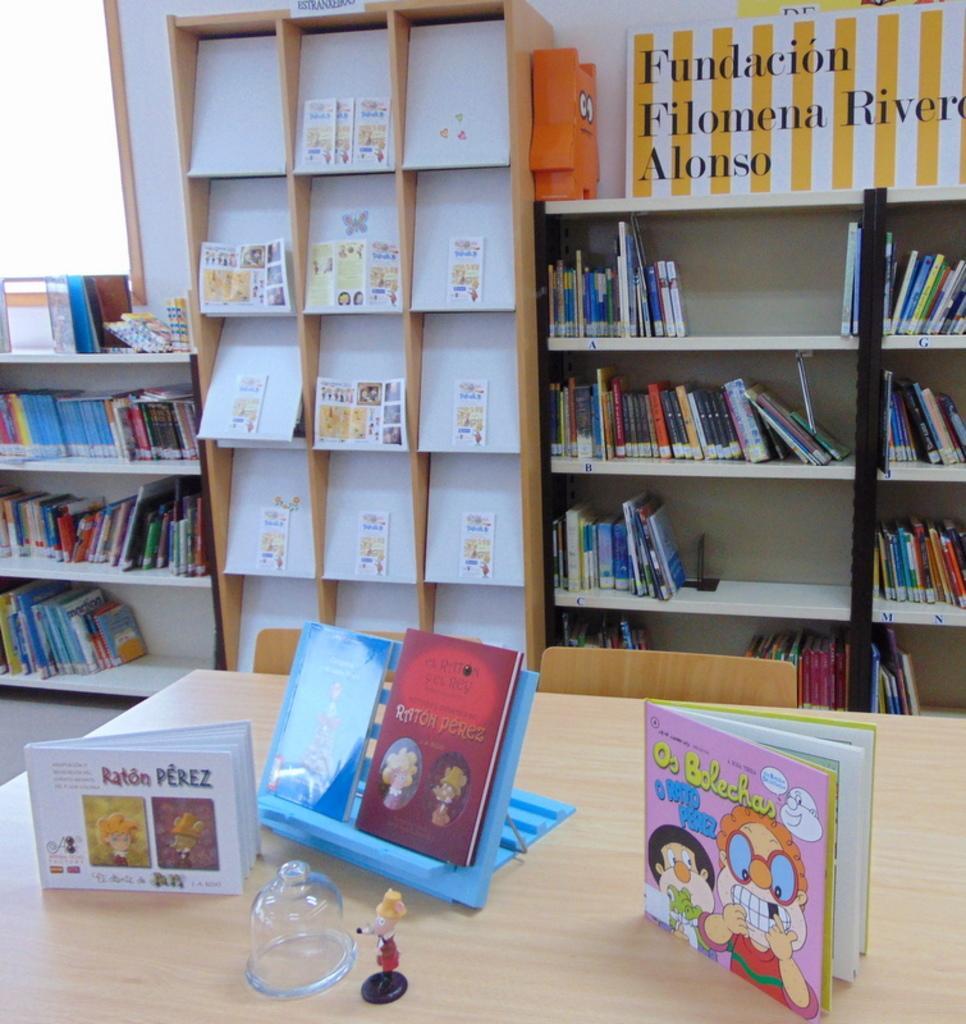Please provide a concise description of this image. In this picture we can see the table with books, toy, stand and a glass object on it. In the background we can see books on shelves, posters and some objects. 